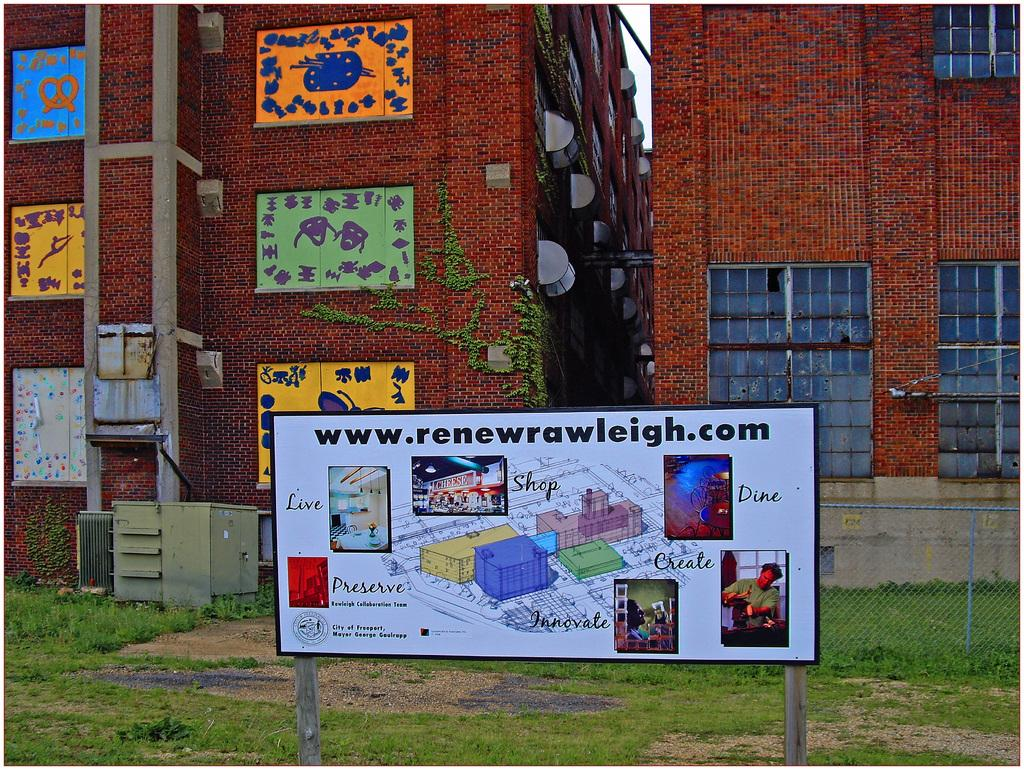<image>
Provide a brief description of the given image. A sign has the website www.renewrawleigh.com on it. 